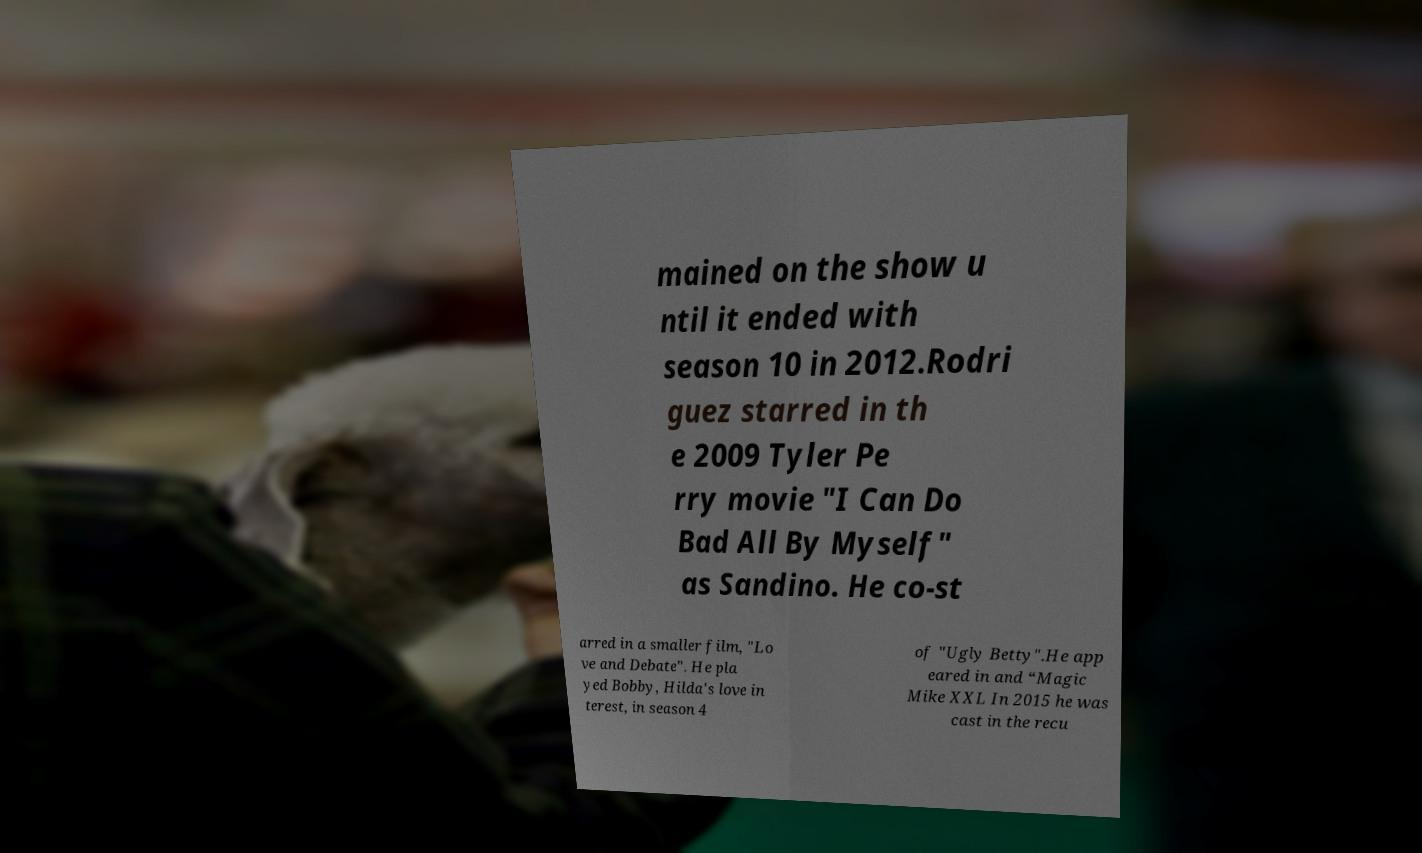Could you assist in decoding the text presented in this image and type it out clearly? mained on the show u ntil it ended with season 10 in 2012.Rodri guez starred in th e 2009 Tyler Pe rry movie "I Can Do Bad All By Myself" as Sandino. He co-st arred in a smaller film, "Lo ve and Debate". He pla yed Bobby, Hilda's love in terest, in season 4 of "Ugly Betty".He app eared in and “Magic Mike XXL In 2015 he was cast in the recu 